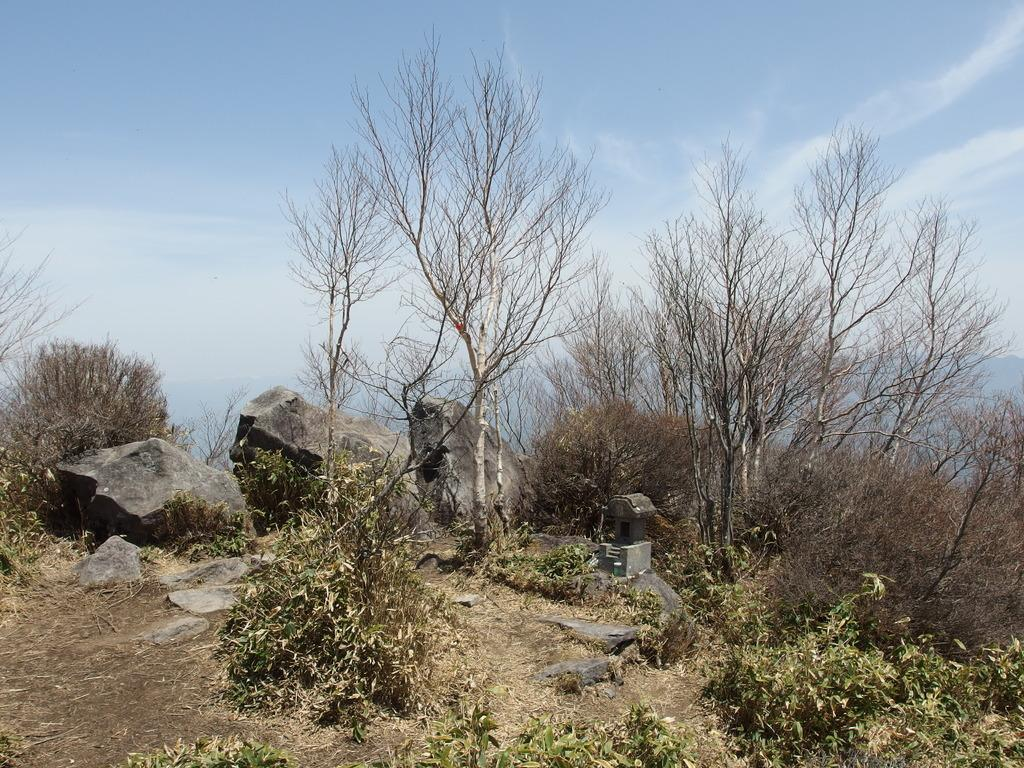What type of natural elements can be seen in the image? Plants, trees, and rocks can be seen in the image. What part of the natural environment is visible in the image? The sky is visible in the image. What can be seen in the sky in the image? There are clouds in the sky. Where is the sink located in the image? There is no sink present in the image. Can you tell me how many uncles are visible in the image? There are no uncles present in the image. What type of sport is being played in the image? There is no sport being played in the image. 